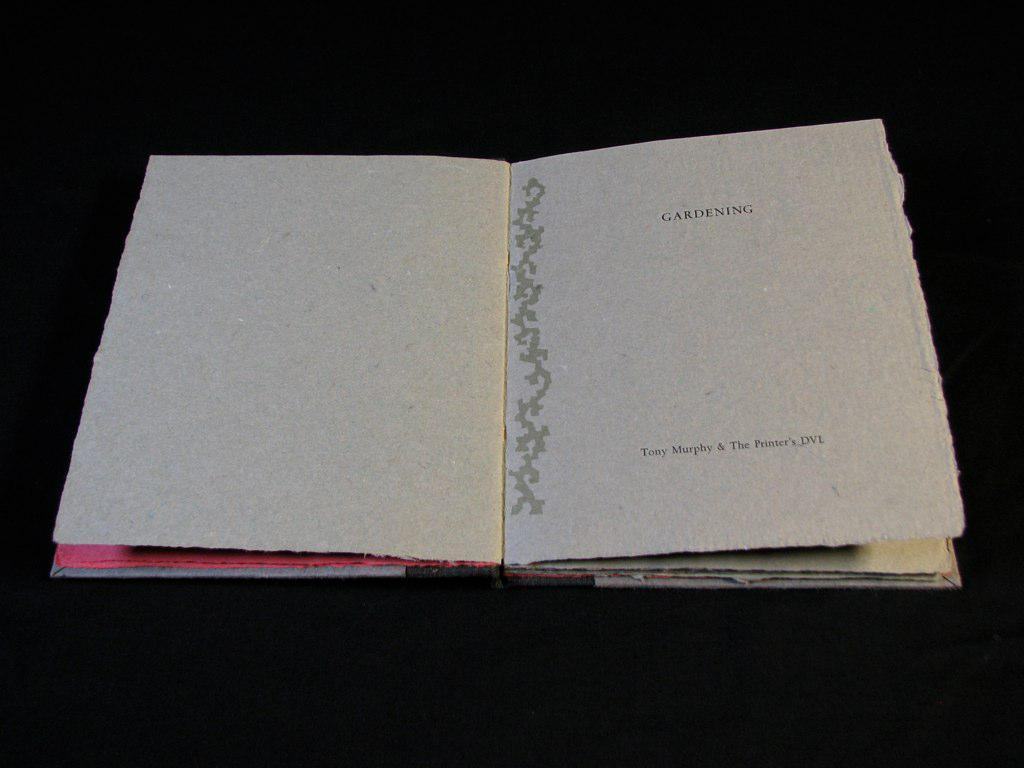<image>
Render a clear and concise summary of the photo. A book opened to a page where the title is Gardening 